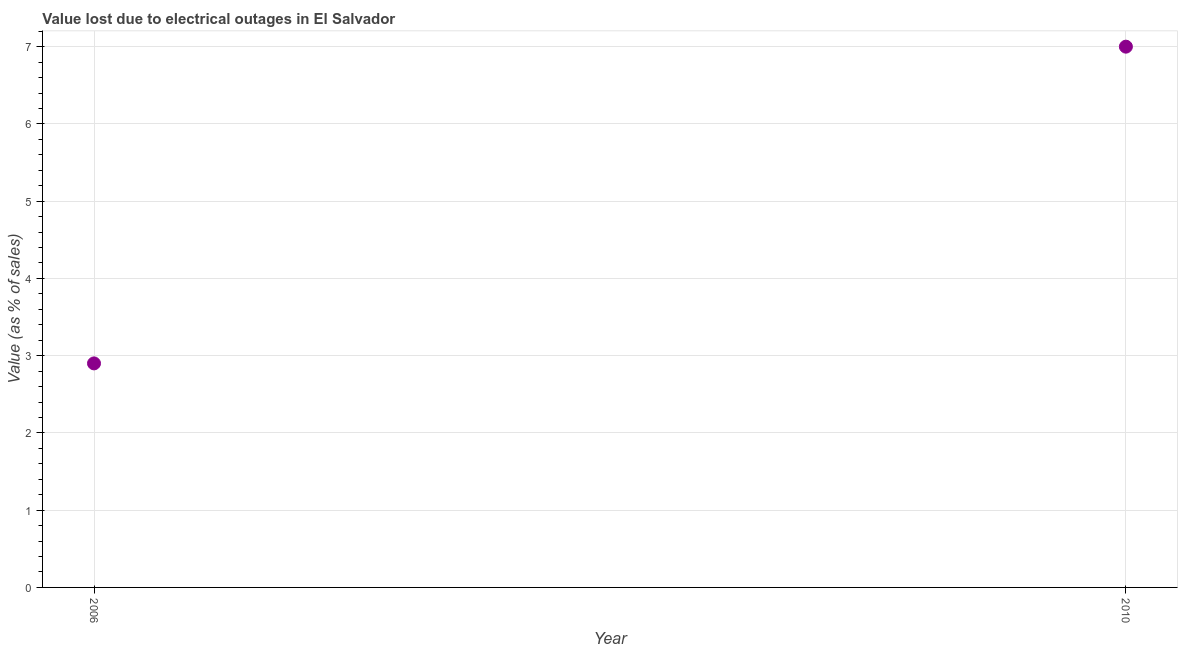Across all years, what is the minimum value lost due to electrical outages?
Provide a short and direct response. 2.9. In which year was the value lost due to electrical outages minimum?
Your answer should be very brief. 2006. What is the difference between the value lost due to electrical outages in 2006 and 2010?
Ensure brevity in your answer.  -4.1. What is the average value lost due to electrical outages per year?
Provide a succinct answer. 4.95. What is the median value lost due to electrical outages?
Make the answer very short. 4.95. In how many years, is the value lost due to electrical outages greater than 2.2 %?
Offer a terse response. 2. What is the ratio of the value lost due to electrical outages in 2006 to that in 2010?
Give a very brief answer. 0.41. Is the value lost due to electrical outages in 2006 less than that in 2010?
Ensure brevity in your answer.  Yes. In how many years, is the value lost due to electrical outages greater than the average value lost due to electrical outages taken over all years?
Your response must be concise. 1. How many years are there in the graph?
Ensure brevity in your answer.  2. What is the title of the graph?
Give a very brief answer. Value lost due to electrical outages in El Salvador. What is the label or title of the Y-axis?
Your response must be concise. Value (as % of sales). What is the Value (as % of sales) in 2010?
Your response must be concise. 7. What is the ratio of the Value (as % of sales) in 2006 to that in 2010?
Offer a very short reply. 0.41. 